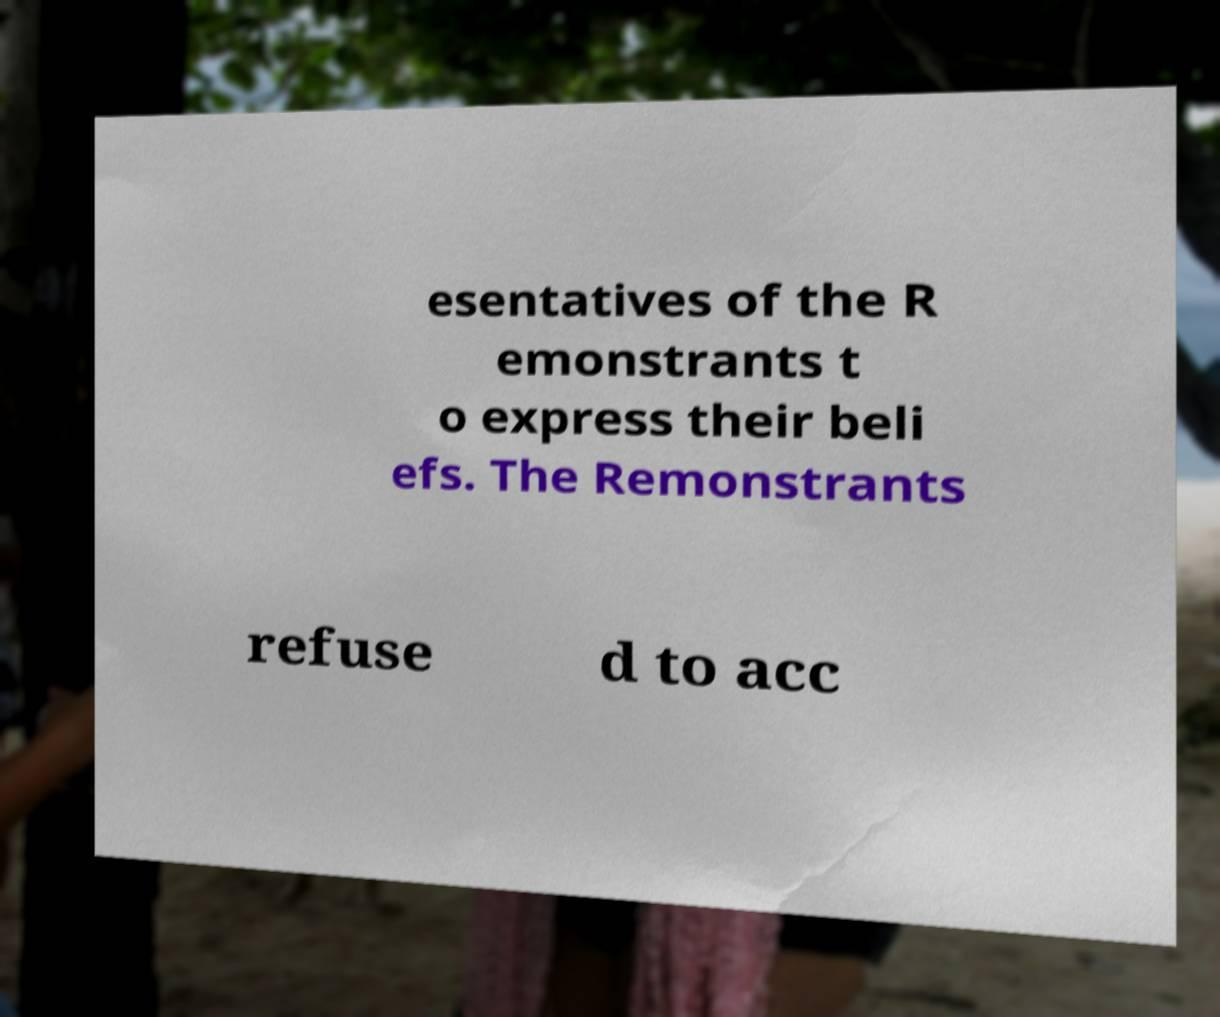I need the written content from this picture converted into text. Can you do that? esentatives of the R emonstrants t o express their beli efs. The Remonstrants refuse d to acc 